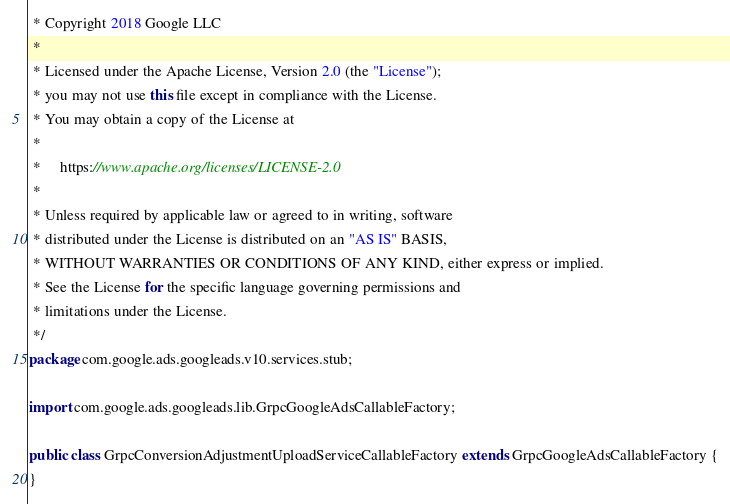Convert code to text. <code><loc_0><loc_0><loc_500><loc_500><_Java_> * Copyright 2018 Google LLC
 *
 * Licensed under the Apache License, Version 2.0 (the "License");
 * you may not use this file except in compliance with the License.
 * You may obtain a copy of the License at
 *
 *     https://www.apache.org/licenses/LICENSE-2.0
 *
 * Unless required by applicable law or agreed to in writing, software
 * distributed under the License is distributed on an "AS IS" BASIS,
 * WITHOUT WARRANTIES OR CONDITIONS OF ANY KIND, either express or implied.
 * See the License for the specific language governing permissions and
 * limitations under the License.
 */
package com.google.ads.googleads.v10.services.stub;

import com.google.ads.googleads.lib.GrpcGoogleAdsCallableFactory;

public class GrpcConversionAdjustmentUploadServiceCallableFactory extends GrpcGoogleAdsCallableFactory {
}
</code> 